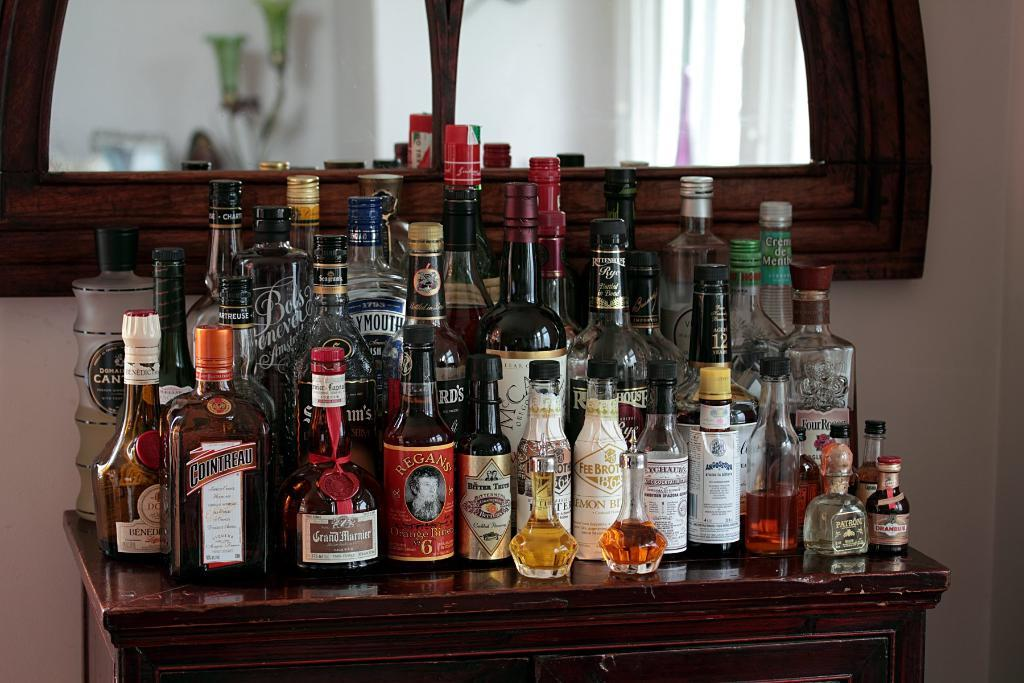Provide a one-sentence caption for the provided image. many bottles of liquor are on a wood table including Cointreau. 